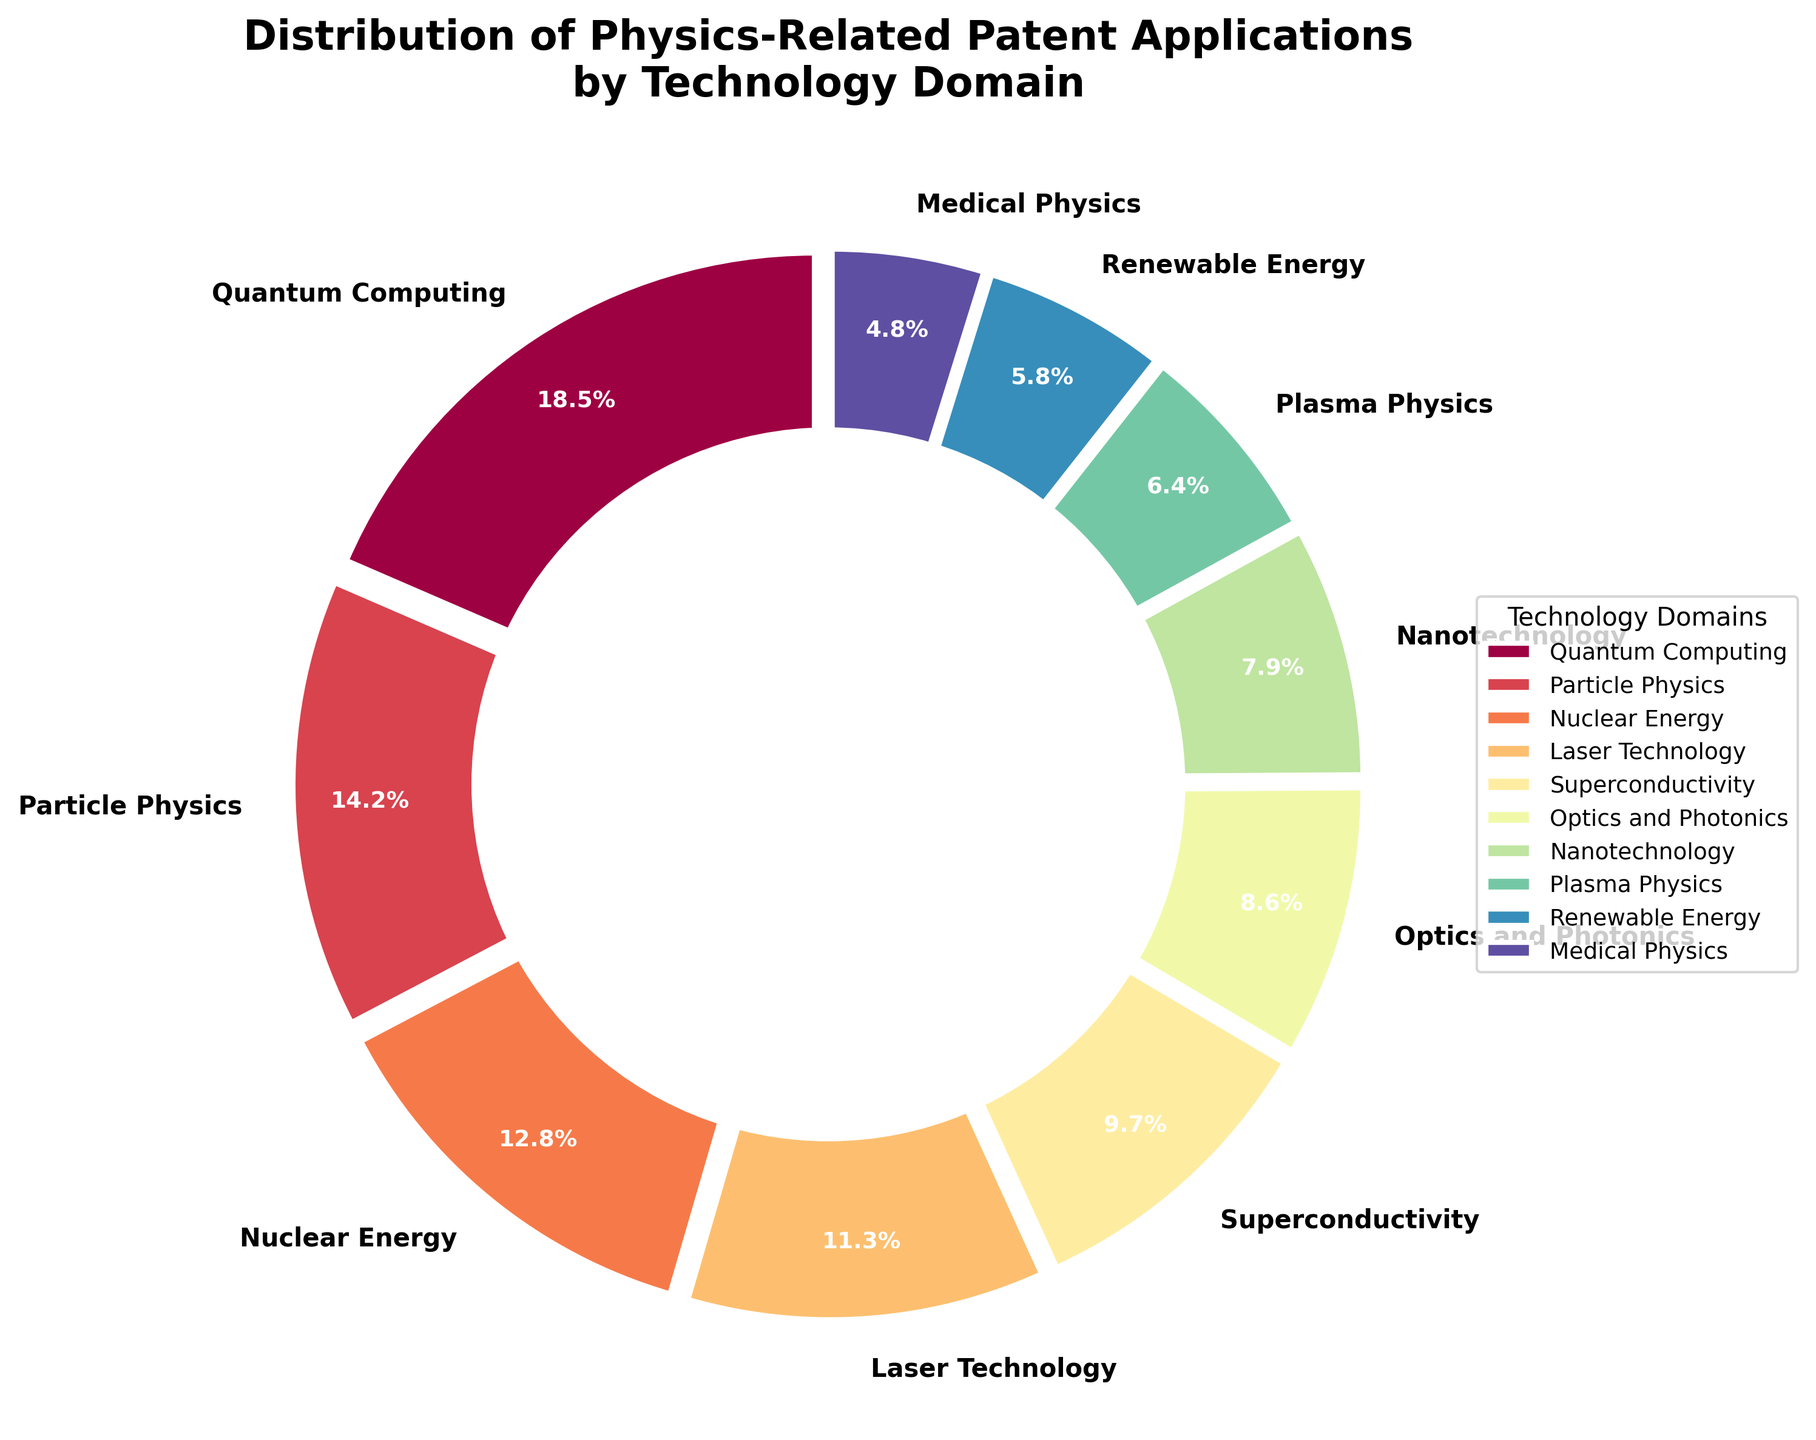What's the most frequent domain in the pie chart? The most frequent domain corresponds to the largest slice in the pie chart, which is Quantum Computing at 18.5%.
Answer: Quantum Computing Which technology domain has the smallest representation in the pie chart? The smallest slice in the pie chart represents the domain with the lowest percentage, which is Medical Physics at 4.8%.
Answer: Medical Physics How much more significant is Quantum Computing compared to Plasma Physics in the patent applications? Quantum Computing is 18.5% while Plasma Physics is 6.4%. So, the difference is 18.5 - 6.4 = 12.1%.
Answer: 12.1% What’s the total percentage for the top three technology domains? The top three domains are Quantum Computing (18.5%), Particle Physics (14.2%), and Nuclear Energy (12.8%). Adding them equals 18.5 + 14.2 + 12.8 = 45.5%.
Answer: 45.5% Which domain has a larger share, Laser Technology or Superconductivity? By comparing the sizes, Laser Technology has 11.3% while Superconductivity has 9.7%. Laser Technology has a larger share.
Answer: Laser Technology What’s the combined percentage of the domains that fall under 10%? Adding up Superconductivity (9.7%), Optics and Photonics (8.6%), Nanotechnology (7.9%), Plasma Physics (6.4%), Renewable Energy (5.8%), and Medical Physics (4.8%) equals 9.7 + 8.6 + 7.9 + 6.4 + 5.8 + 4.8 = 43.2%.
Answer: 43.2% Is Renewable Energy closer in percentage to Nuclear Energy or to Medical Physics? Renewable Energy has 5.8%. The difference with Nuclear Energy (12.8%) is 12.8 - 5.8 = 7%. The difference with Medical Physics (4.8%) is 5.8 - 4.8 = 1%. Renewable Energy is closer to Medical Physics.
Answer: Medical Physics What is the average percentage of all technology domains represented? Sum all percentages 18.5 + 14.2 + 12.8 + 11.3 + 9.7 + 8.6 + 7.9 + 6.4 + 5.8 + 4.8 = 100%. Since there are 10 domains, the average is 100 / 10 = 10%.
Answer: 10% What’s the difference between the domain with the highest percentage and the combined percentage of the two least represented domains? The highest is Quantum Computing at 18.5%. The two smallest, Medical Physics (4.8%) and Renewable Energy (5.8%), together equal 4.8 + 5.8 = 10.6%. The difference is 18.5 - 10.6 = 7.9%.
Answer: 7.9% Which domains are represented with over 10%? The domains with slices over 10% are Quantum Computing (18.5%), Particle Physics (14.2%), Nuclear Energy (12.8%), and Laser Technology (11.3%).
Answer: Quantum Computing, Particle Physics, Nuclear Energy, Laser Technology 